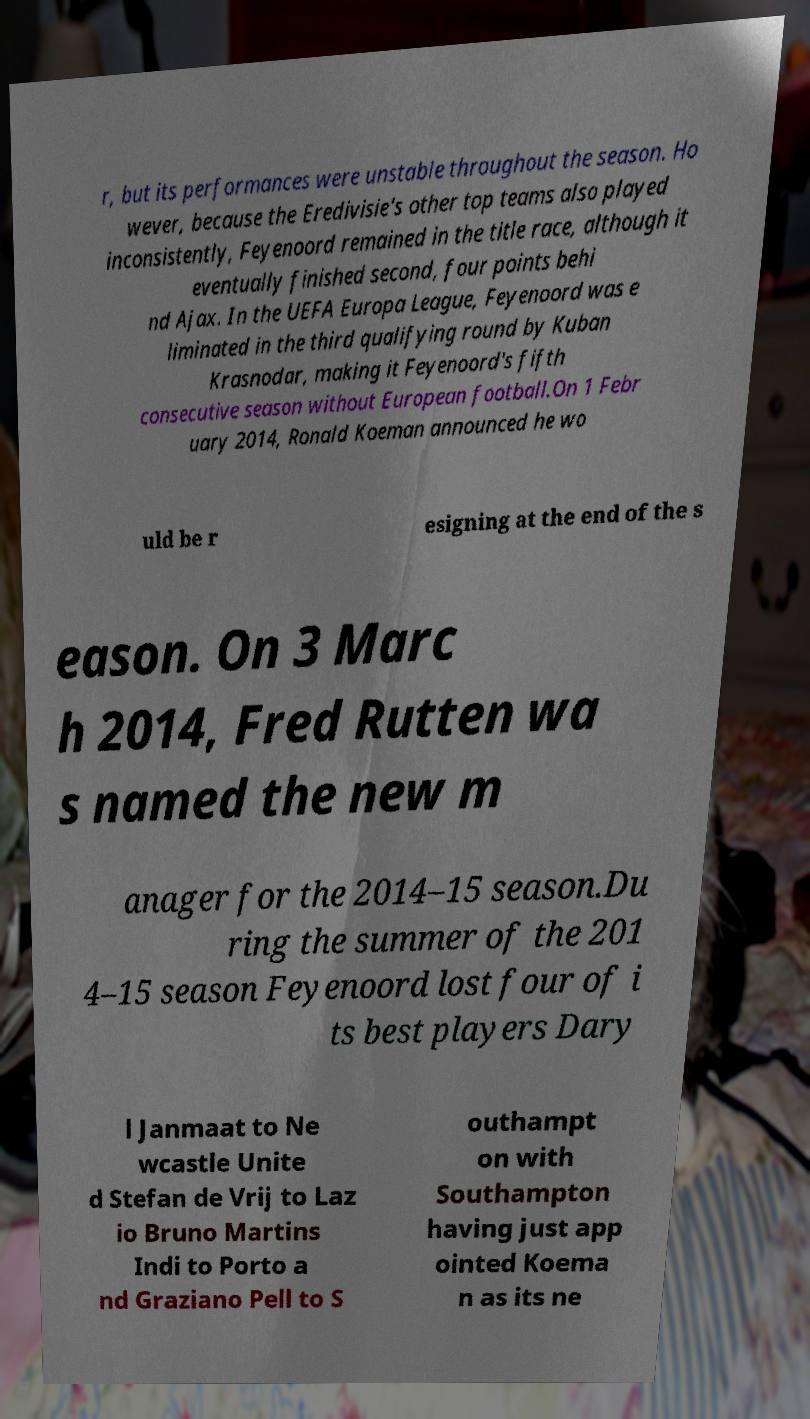Could you extract and type out the text from this image? r, but its performances were unstable throughout the season. Ho wever, because the Eredivisie's other top teams also played inconsistently, Feyenoord remained in the title race, although it eventually finished second, four points behi nd Ajax. In the UEFA Europa League, Feyenoord was e liminated in the third qualifying round by Kuban Krasnodar, making it Feyenoord's fifth consecutive season without European football.On 1 Febr uary 2014, Ronald Koeman announced he wo uld be r esigning at the end of the s eason. On 3 Marc h 2014, Fred Rutten wa s named the new m anager for the 2014–15 season.Du ring the summer of the 201 4–15 season Feyenoord lost four of i ts best players Dary l Janmaat to Ne wcastle Unite d Stefan de Vrij to Laz io Bruno Martins Indi to Porto a nd Graziano Pell to S outhampt on with Southampton having just app ointed Koema n as its ne 